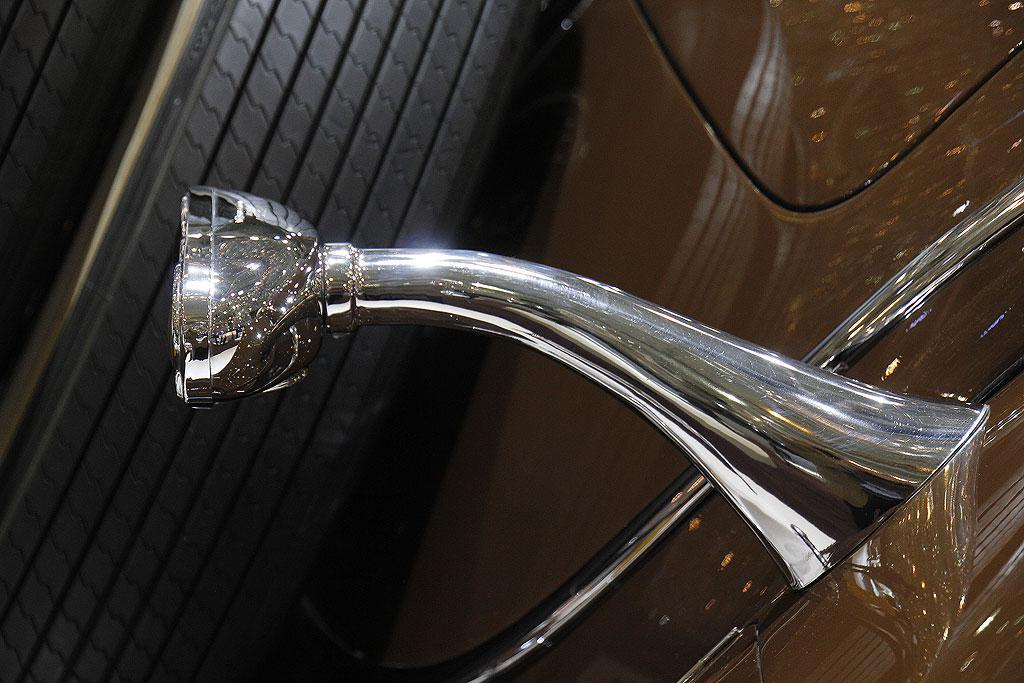What is the main subject of the image? The main subject of the image is a car. Can you describe any specific features of the car? There is a metal object on the car. What type of tire can be seen in the image? There is a black tire in the image. How many units of houses are visible in the image? There are no houses present in the image, so it is not possible to determine the number of units. 